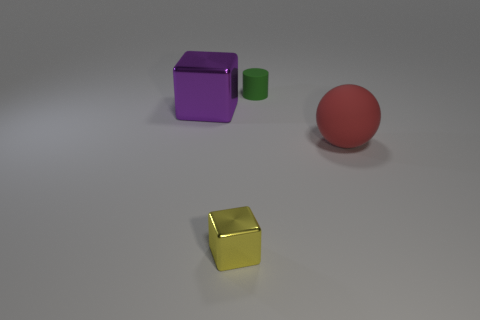Add 3 large shiny blocks. How many objects exist? 7 Subtract all balls. How many objects are left? 3 Subtract all green balls. How many purple blocks are left? 1 Subtract all objects. Subtract all large yellow objects. How many objects are left? 0 Add 3 small things. How many small things are left? 5 Add 3 spheres. How many spheres exist? 4 Subtract all purple blocks. How many blocks are left? 1 Subtract 0 green blocks. How many objects are left? 4 Subtract 1 balls. How many balls are left? 0 Subtract all blue blocks. Subtract all green cylinders. How many blocks are left? 2 